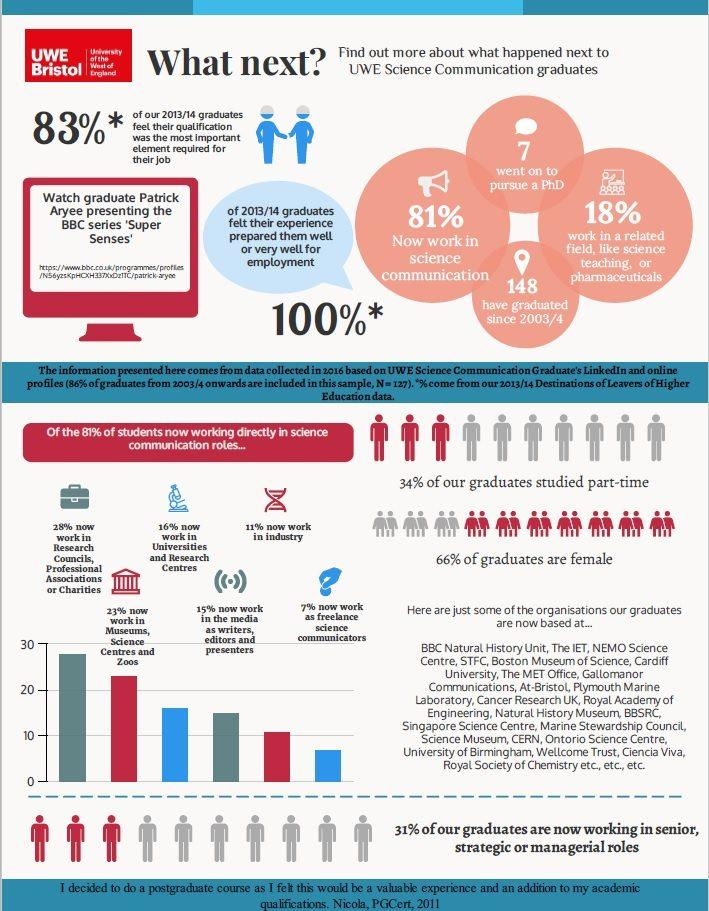Draw attention to some important aspects in this diagram. In the 2013/14 batch of UWE science communication graduates, 34% of the male students. A survey of students who have graduated in the past three years found that 7% of them are currently working as freelance science communicators. Since 2003/2004, a total of 148 science communication graduates have been produced by the University of the West of England. A study found that 19% of UWE science communication graduates do not work in the same stream as their degree. Seven UWE science communication graduates from the 2013/14 batch went on to pursue a PhD. 